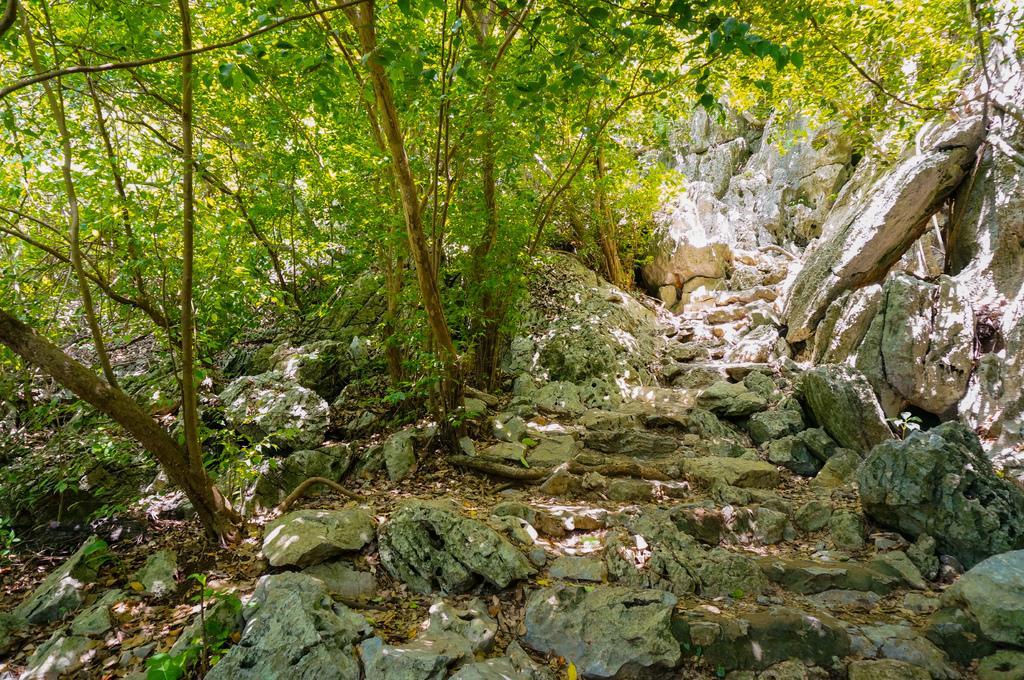Could you give a brief overview of what you see in this image? In this picture we can see many trees. On the right we can see the stones. At the bottom we can see the grass and leaves. 